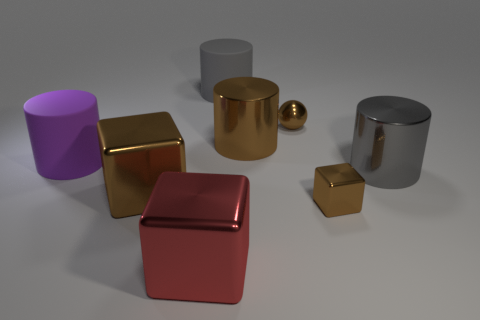What is the color of the small ball that is the same material as the red thing?
Provide a succinct answer. Brown. Is there a purple metal sphere that has the same size as the purple matte object?
Make the answer very short. No. Is the color of the large shiny object that is behind the big purple cylinder the same as the sphere?
Give a very brief answer. Yes. What is the color of the shiny thing that is to the left of the brown cylinder and behind the small brown metallic block?
Offer a terse response. Brown. There is a purple rubber object that is the same size as the red object; what is its shape?
Your answer should be compact. Cylinder. Are there any other objects of the same shape as the red shiny object?
Offer a terse response. Yes. There is a gray cylinder to the left of the gray shiny object; is its size the same as the brown cylinder?
Keep it short and to the point. Yes. There is a thing that is both to the left of the big red metal thing and in front of the large gray shiny cylinder; how big is it?
Ensure brevity in your answer.  Large. How many other things are made of the same material as the small brown sphere?
Your answer should be very brief. 5. There is a rubber cylinder on the right side of the purple thing; what is its size?
Provide a short and direct response. Large. 